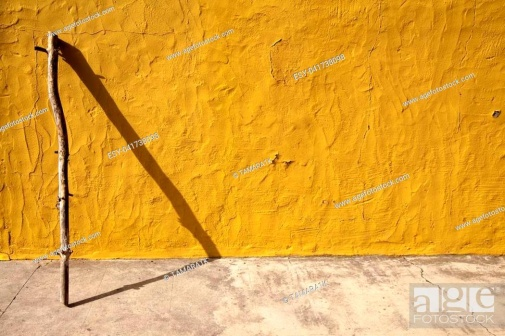In what kind of scenario might this stick and wall become central elements? Short scenario: In a small, quaint village, the stick and wall serve as a discreet meeting point for secret messages among villagers, fostering a sense of mystery and camaraderie.

Long scenario: During a village festival, the stick-cum-wall becomes a symbolic centerpiece. Local legend speaks of a wise elder who, long ago, planted the stick there to bless the village with prosperity. Each year, villagers gather around this humble shrine, adorning it with flowers and ribbons, sharing stories passed down through generations. The stick and wall, witnesses to time's passage, stand as testaments to the village's enduring spirit and rich heritage. 